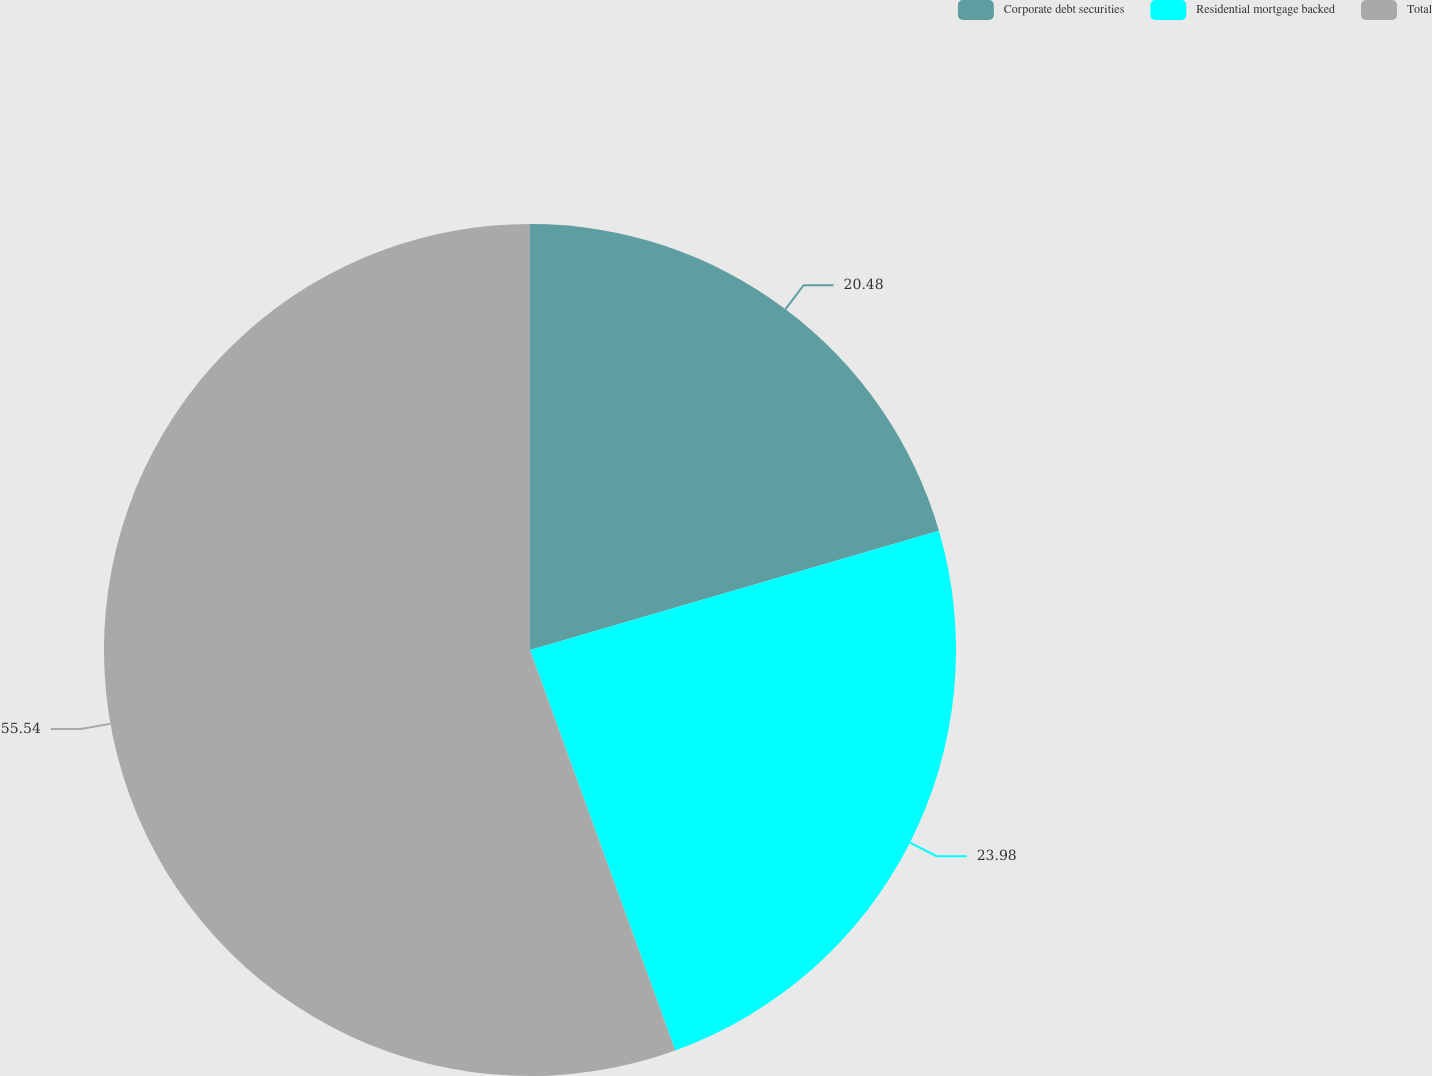Convert chart. <chart><loc_0><loc_0><loc_500><loc_500><pie_chart><fcel>Corporate debt securities<fcel>Residential mortgage backed<fcel>Total<nl><fcel>20.48%<fcel>23.98%<fcel>55.54%<nl></chart> 